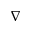<formula> <loc_0><loc_0><loc_500><loc_500>\nabla</formula> 